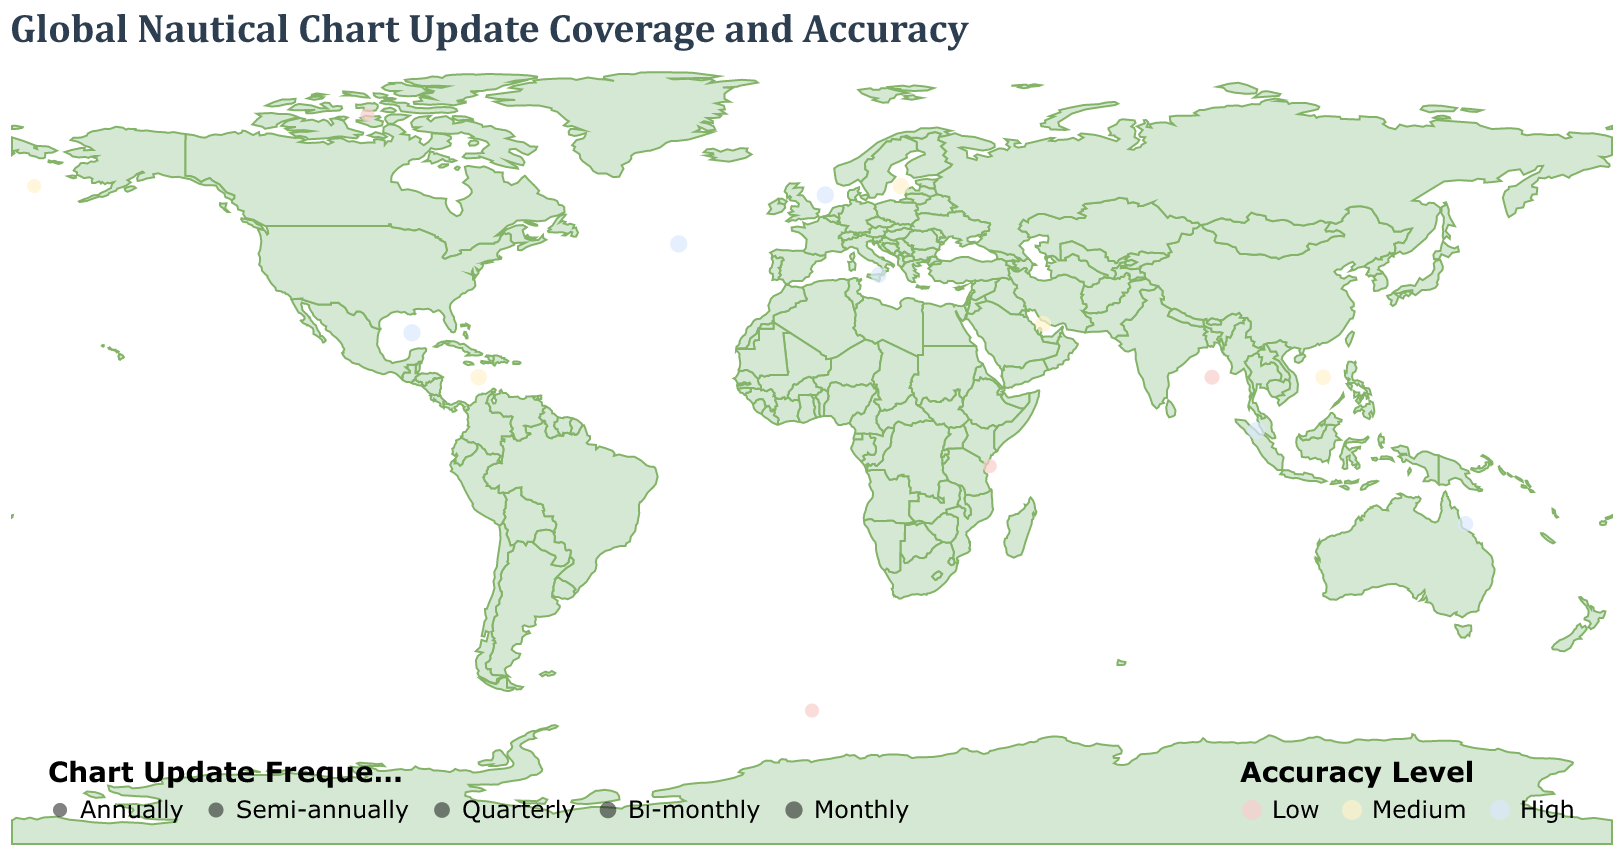What is the chart update frequency for the North Atlantic region? The North Atlantic region is represented by a circle on the map, and according to the figure, its chart update frequency is indicated in the tooltip as "Monthly".
Answer: Monthly How many regions have a high accuracy level for their nautical charts? By identifying the circles colored in blue (indicating high accuracy), we count the regions: North Atlantic, Mediterranean Sea, North Sea, Gulf of Mexico, Great Barrier Reef, Strait of Malacca.
Answer: 6 Which region has the lowest accuracy level and only updates its chart annually? Look for regions with low accuracy, marked in light pink, and check their update frequency. East African Coast, Southern Ocean, and Northwest Passage all have low accuracy and update annually.
Answer: East African Coast, Southern Ocean, Northwest Passage What is the chart update frequency and accuracy level for the Persian Gulf? According to the tooltip information for the Persian Gulf, it has a chart update frequency of "Quarterly" and an accuracy level of "Medium".
Answer: Quarterly, Medium Compare the chart update frequency and accuracy level between the North Sea and the Baltic Sea. According to the data, the North Sea has a monthly chart update frequency and a high accuracy level. The Baltic Sea has a bi-monthly chart update frequency and a medium accuracy level.
Answer: North Sea: Monthly, High; Baltic Sea: Bi-monthly, Medium Which region has a higher chart update frequency, the Caribbean Sea or the Strait of Malacca? The Caribbean Sea updates its charts bi-monthly, while the Strait of Malacca updates its charts monthly. Monthly is more frequent than bi-monthly.
Answer: Strait of Malacca Among the listed regions, which one is located the farthest north, judging by their latitude? By comparing latitude values, the Northwest Passage has the highest latitude at 74.0, making it the farthest north.
Answer: Northwest Passage How many regions have their chart updated quarterly? The regions with quarterly updates are Mediterranean Sea, South China Sea, Persian Gulf, Great Barrier Reef.
Answer: 4 Which regions have the "Low" accuracy level? The regions indicated in light pink, representing low accuracy, are: East African Coast, Bay of Bengal, Southern Ocean, Northwest Passage.
Answer: East African Coast, Bay of Bengal, Southern Ocean, Northwest Passage Find the region located at approximately longitude 52.0 and latitude 27.0, and state its chart update frequency and accuracy level. The region located at longitude 52.0 and latitude 27.0 is the Persian Gulf. According to its tooltip, its chart update frequency is "Quarterly" and its accuracy level is "Medium".
Answer: Persian Gulf, Quarterly, Medium 